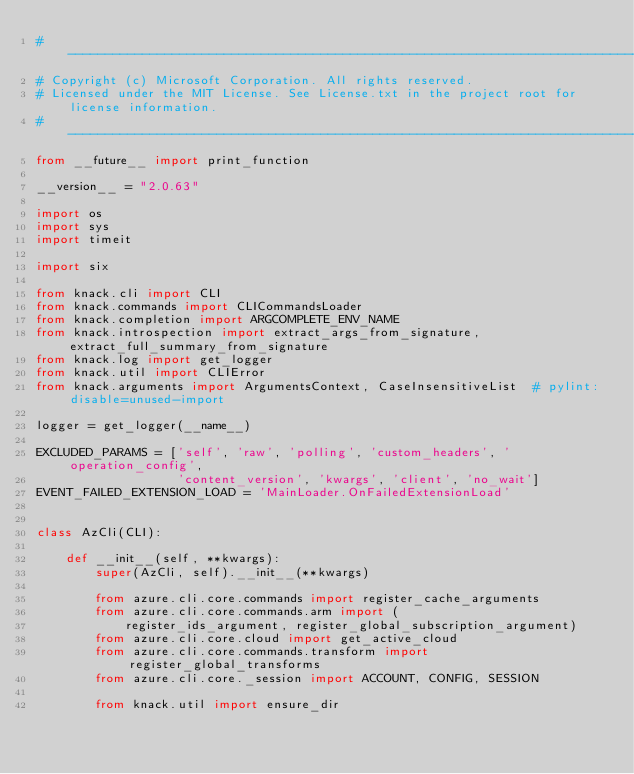Convert code to text. <code><loc_0><loc_0><loc_500><loc_500><_Python_># --------------------------------------------------------------------------------------------
# Copyright (c) Microsoft Corporation. All rights reserved.
# Licensed under the MIT License. See License.txt in the project root for license information.
# --------------------------------------------------------------------------------------------
from __future__ import print_function

__version__ = "2.0.63"

import os
import sys
import timeit

import six

from knack.cli import CLI
from knack.commands import CLICommandsLoader
from knack.completion import ARGCOMPLETE_ENV_NAME
from knack.introspection import extract_args_from_signature, extract_full_summary_from_signature
from knack.log import get_logger
from knack.util import CLIError
from knack.arguments import ArgumentsContext, CaseInsensitiveList  # pylint: disable=unused-import

logger = get_logger(__name__)

EXCLUDED_PARAMS = ['self', 'raw', 'polling', 'custom_headers', 'operation_config',
                   'content_version', 'kwargs', 'client', 'no_wait']
EVENT_FAILED_EXTENSION_LOAD = 'MainLoader.OnFailedExtensionLoad'


class AzCli(CLI):

    def __init__(self, **kwargs):
        super(AzCli, self).__init__(**kwargs)

        from azure.cli.core.commands import register_cache_arguments
        from azure.cli.core.commands.arm import (
            register_ids_argument, register_global_subscription_argument)
        from azure.cli.core.cloud import get_active_cloud
        from azure.cli.core.commands.transform import register_global_transforms
        from azure.cli.core._session import ACCOUNT, CONFIG, SESSION

        from knack.util import ensure_dir
</code> 